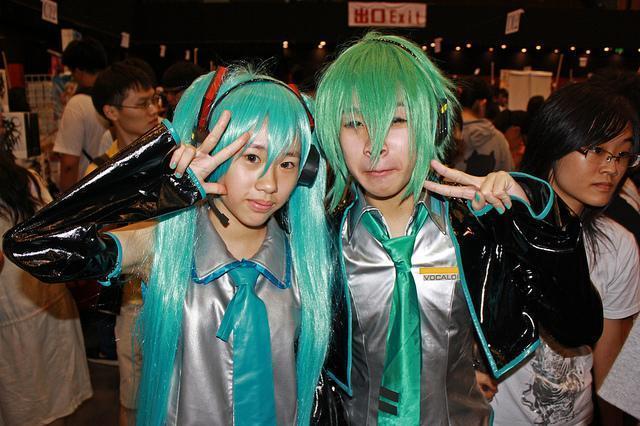How many ties are there?
Give a very brief answer. 2. How many people are in the photo?
Give a very brief answer. 7. 